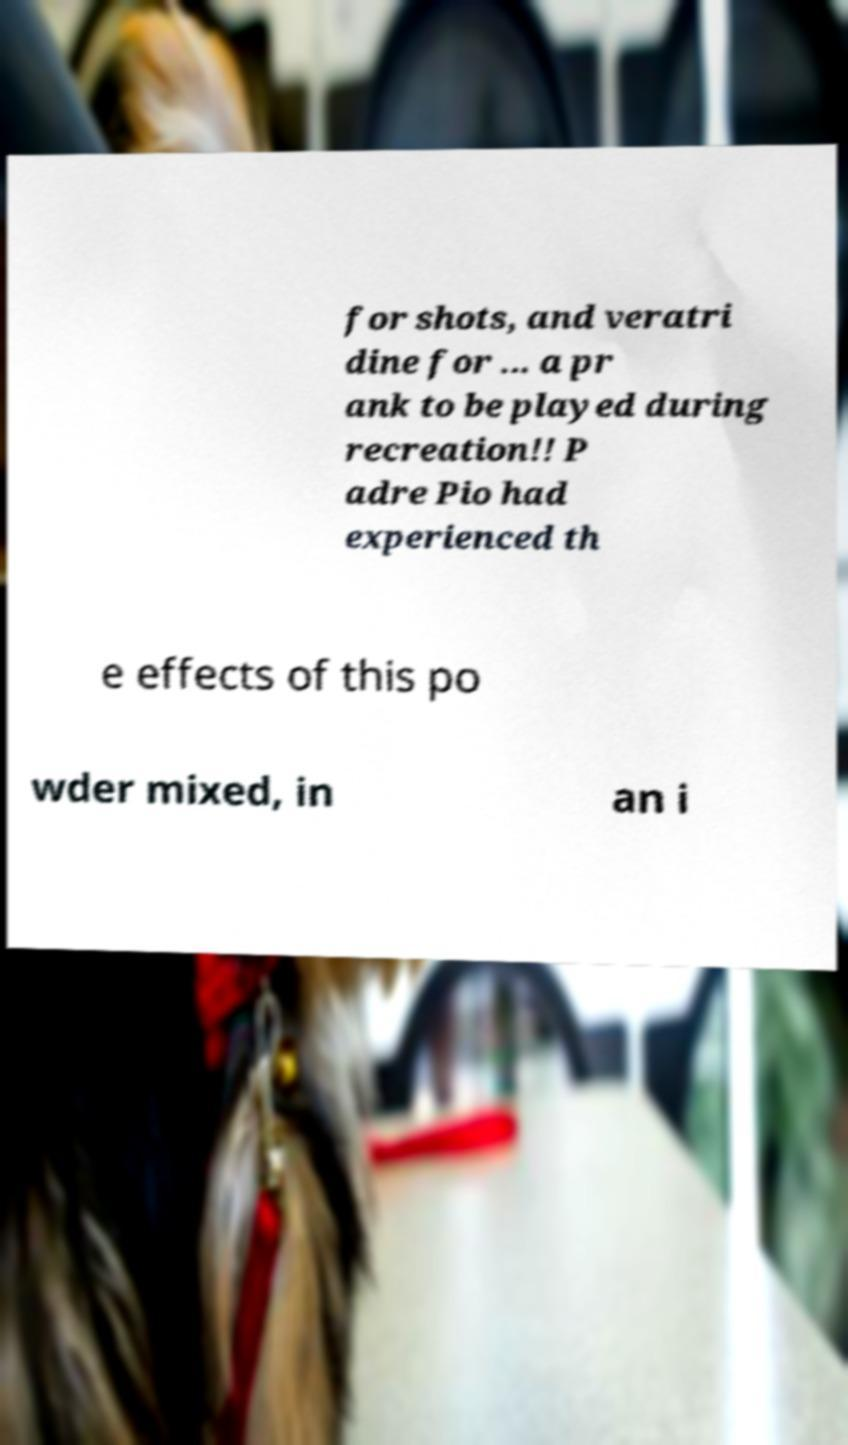Could you assist in decoding the text presented in this image and type it out clearly? for shots, and veratri dine for ... a pr ank to be played during recreation!! P adre Pio had experienced th e effects of this po wder mixed, in an i 